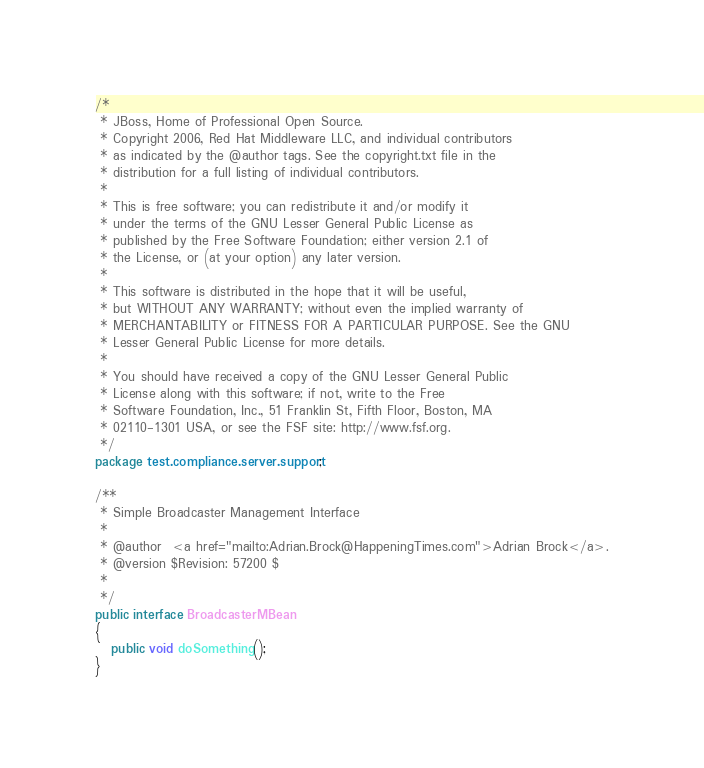<code> <loc_0><loc_0><loc_500><loc_500><_Java_>/*
 * JBoss, Home of Professional Open Source.
 * Copyright 2006, Red Hat Middleware LLC, and individual contributors
 * as indicated by the @author tags. See the copyright.txt file in the
 * distribution for a full listing of individual contributors.
 *
 * This is free software; you can redistribute it and/or modify it
 * under the terms of the GNU Lesser General Public License as
 * published by the Free Software Foundation; either version 2.1 of
 * the License, or (at your option) any later version.
 *
 * This software is distributed in the hope that it will be useful,
 * but WITHOUT ANY WARRANTY; without even the implied warranty of
 * MERCHANTABILITY or FITNESS FOR A PARTICULAR PURPOSE. See the GNU
 * Lesser General Public License for more details.
 *
 * You should have received a copy of the GNU Lesser General Public
 * License along with this software; if not, write to the Free
 * Software Foundation, Inc., 51 Franklin St, Fifth Floor, Boston, MA
 * 02110-1301 USA, or see the FSF site: http://www.fsf.org.
 */
package test.compliance.server.support;

/**
 * Simple Broadcaster Management Interface
 *
 * @author  <a href="mailto:Adrian.Brock@HappeningTimes.com">Adrian Brock</a>.
 * @version $Revision: 57200 $
 *   
 */
public interface BroadcasterMBean
{
   public void doSomething();
}
</code> 